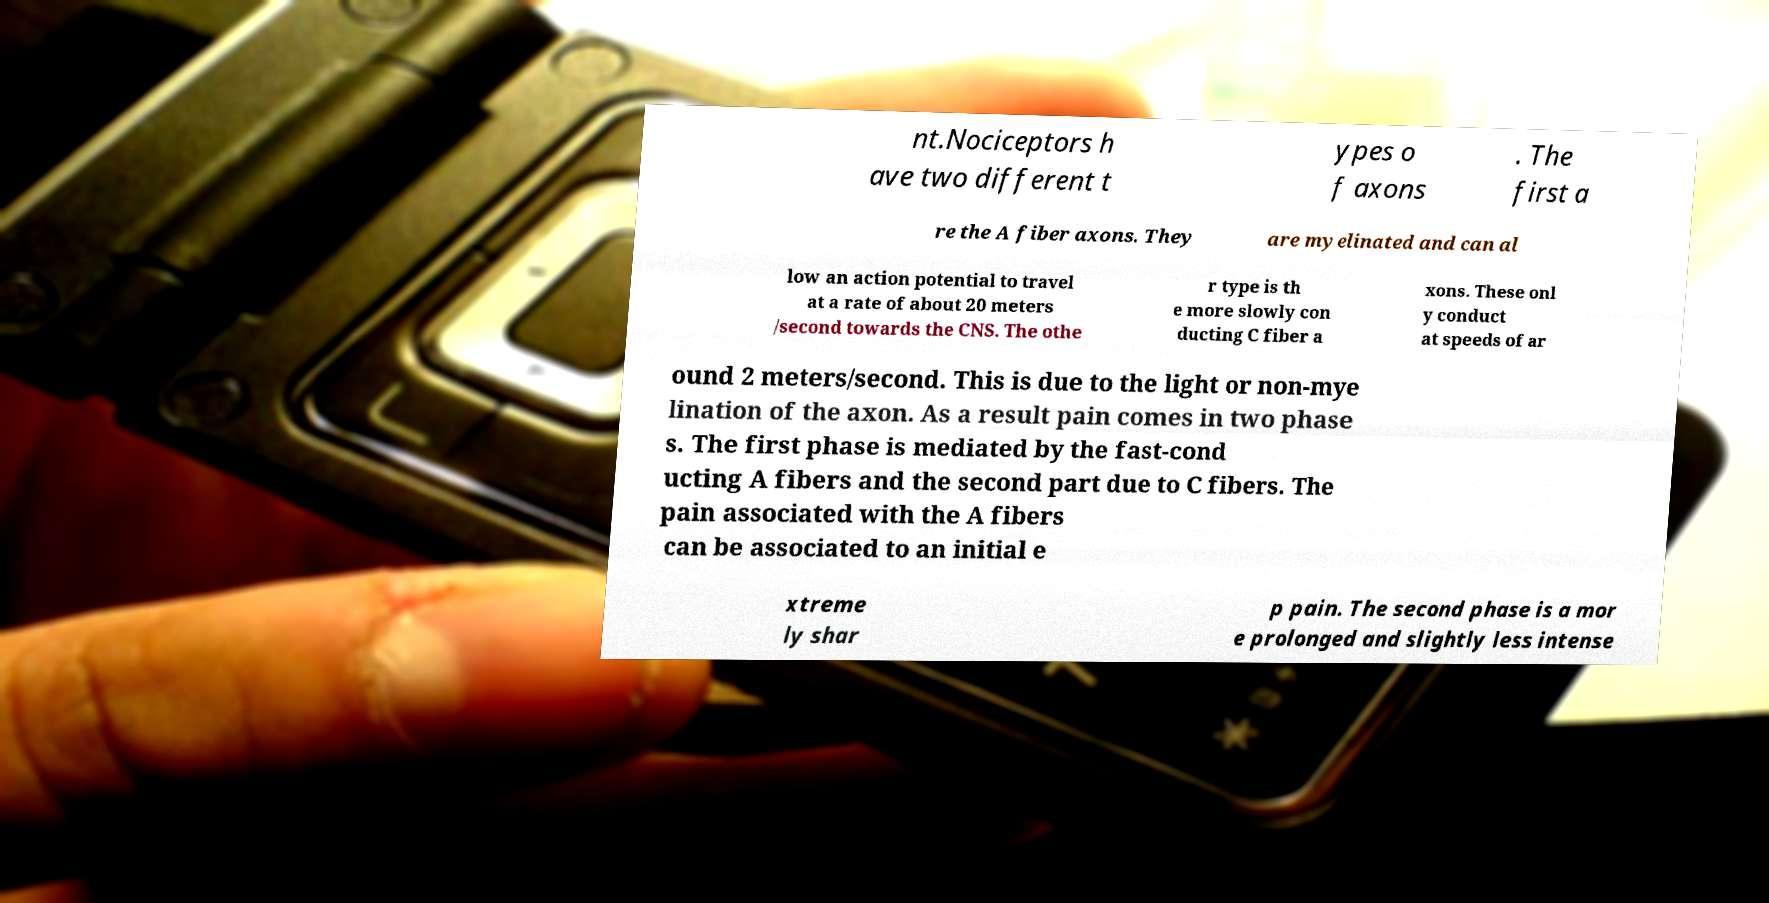For documentation purposes, I need the text within this image transcribed. Could you provide that? nt.Nociceptors h ave two different t ypes o f axons . The first a re the A fiber axons. They are myelinated and can al low an action potential to travel at a rate of about 20 meters /second towards the CNS. The othe r type is th e more slowly con ducting C fiber a xons. These onl y conduct at speeds of ar ound 2 meters/second. This is due to the light or non-mye lination of the axon. As a result pain comes in two phase s. The first phase is mediated by the fast-cond ucting A fibers and the second part due to C fibers. The pain associated with the A fibers can be associated to an initial e xtreme ly shar p pain. The second phase is a mor e prolonged and slightly less intense 